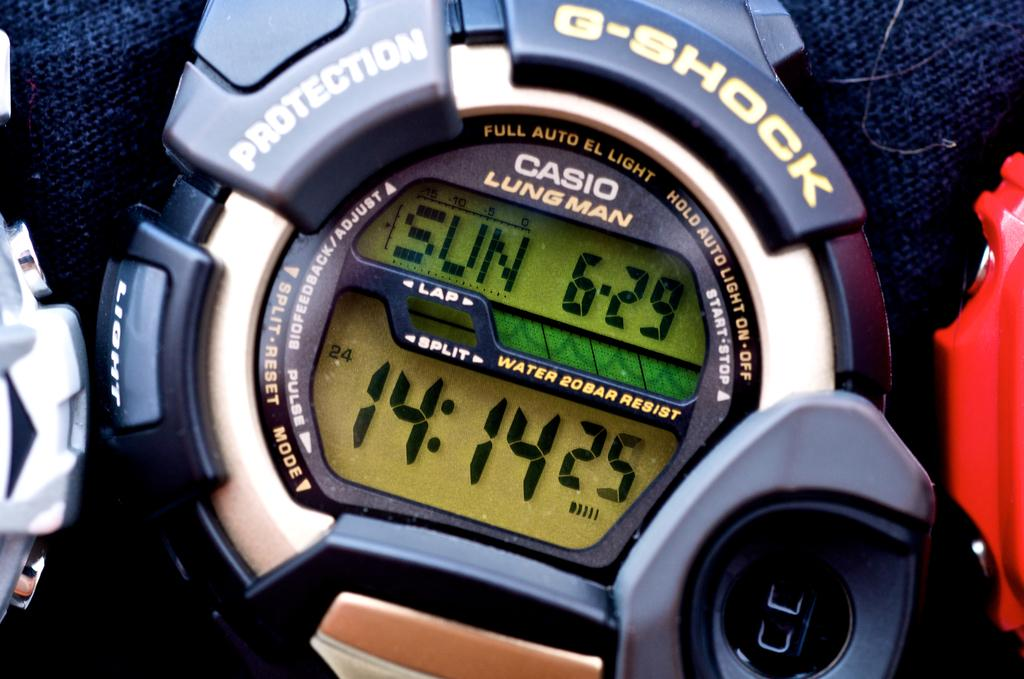Provide a one-sentence caption for the provided image. A G-Shock stopwatch with the time set at "14:14". 